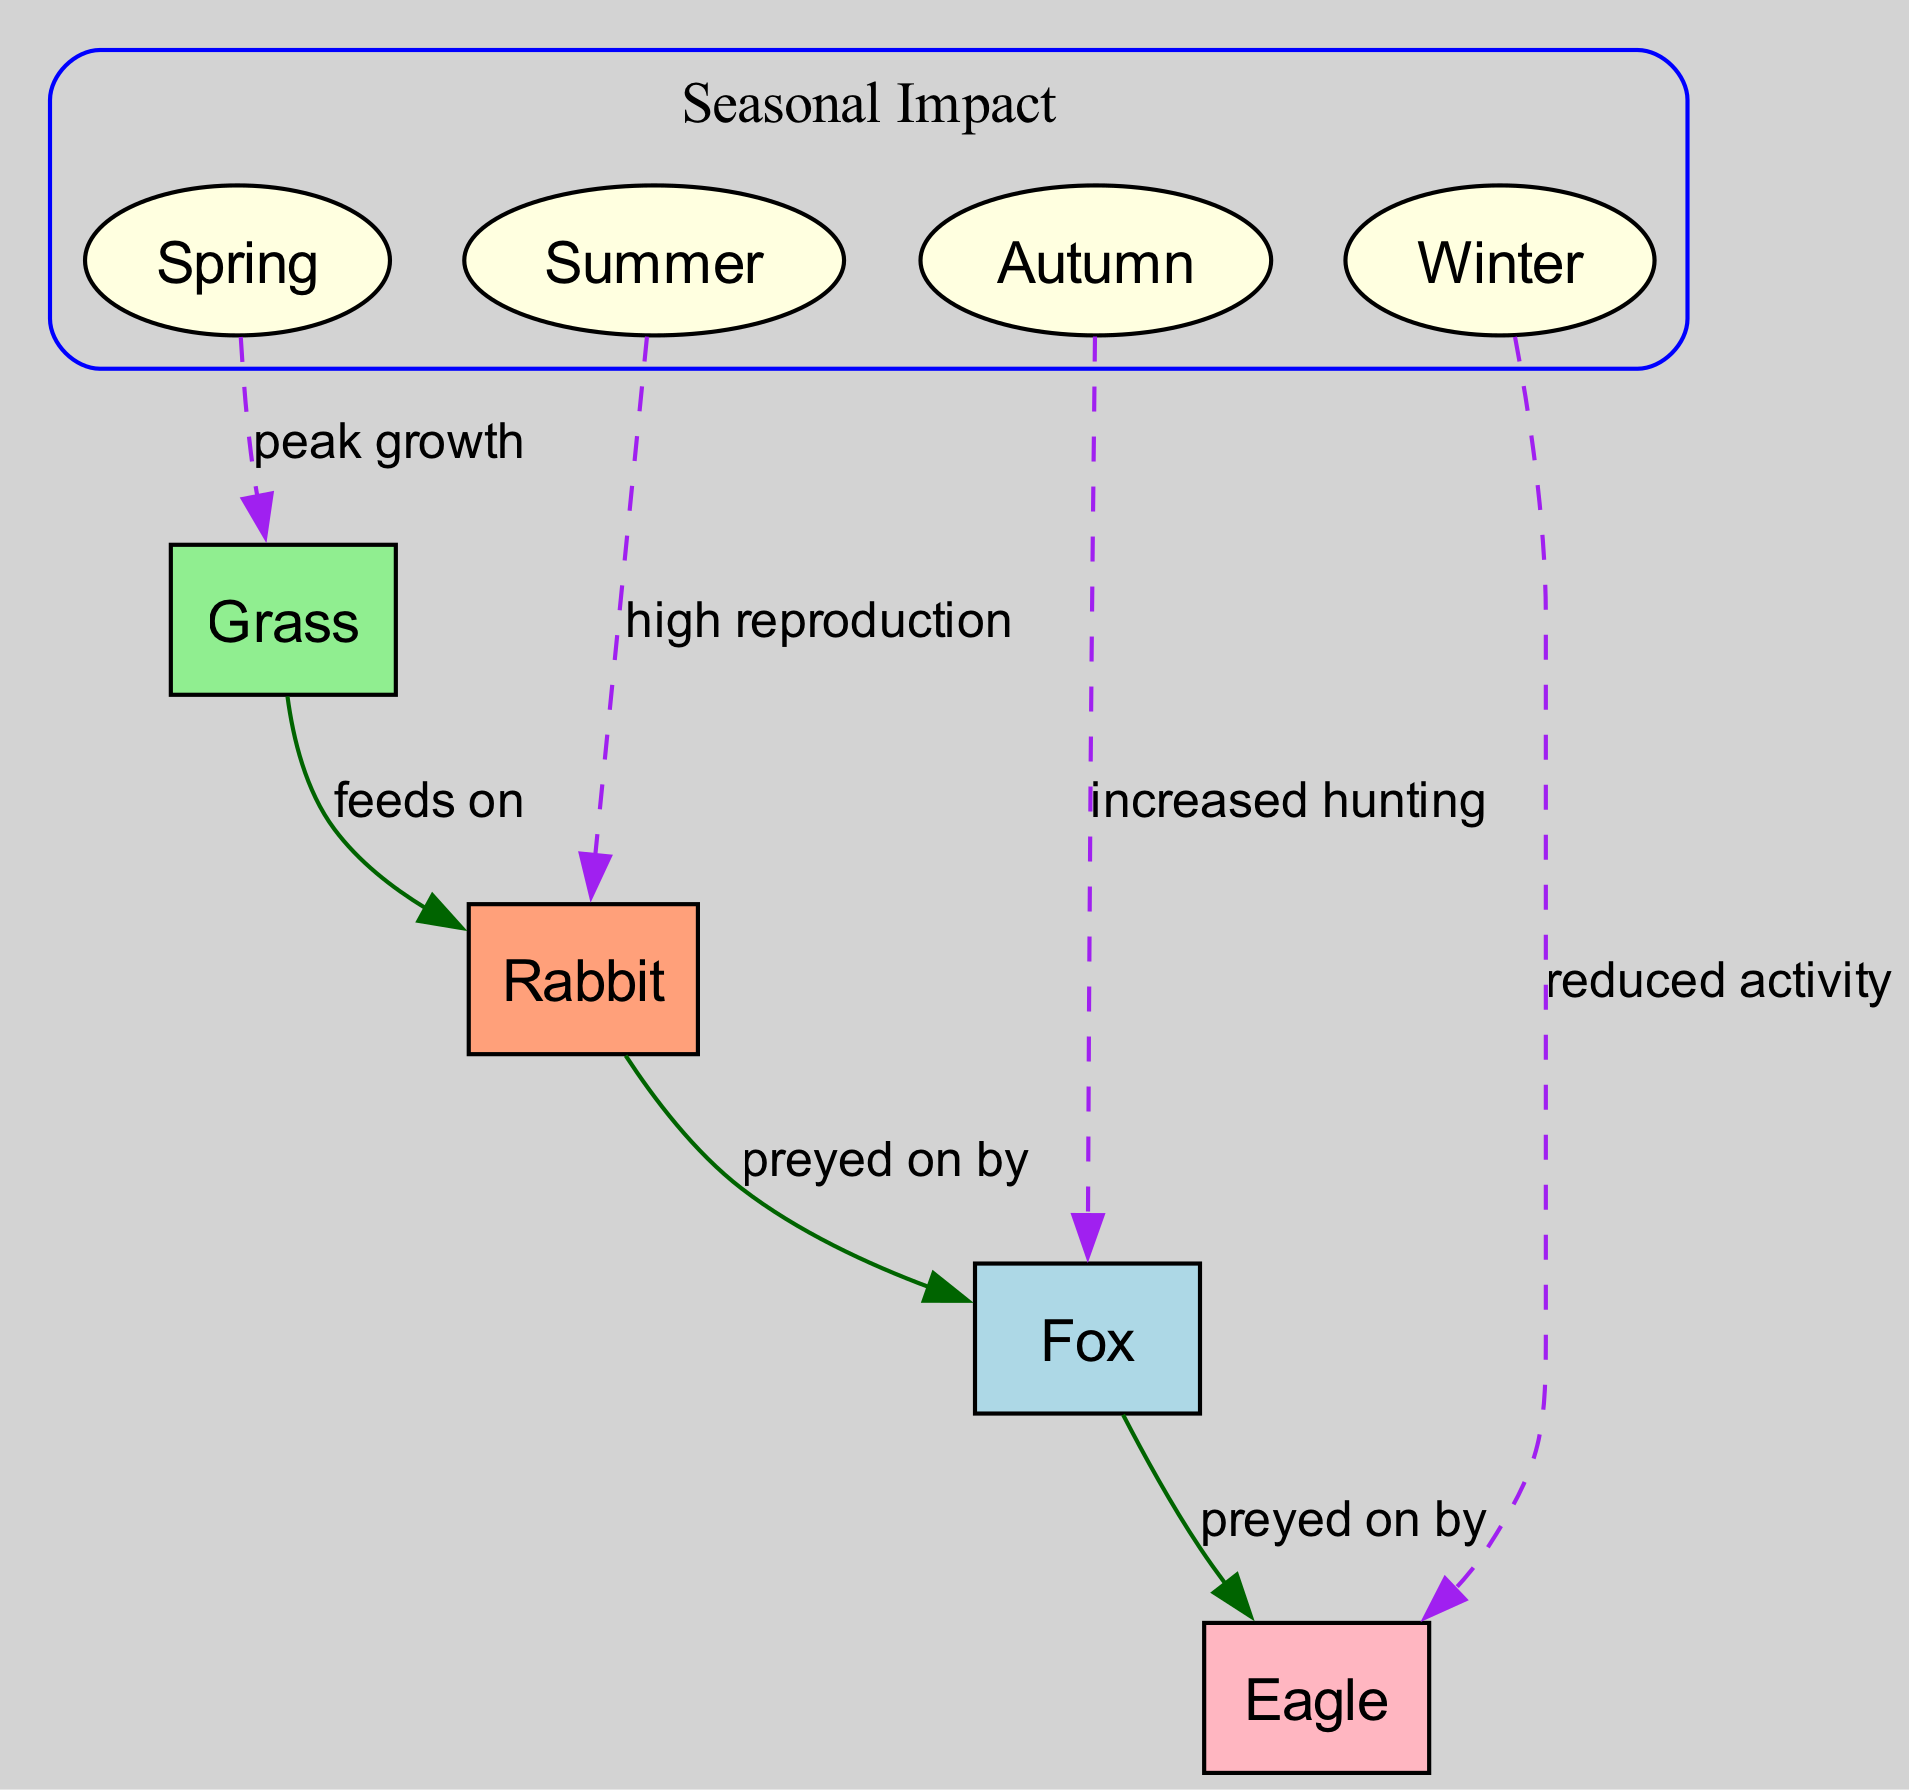What is the main food source for herbivores in the diagram? The diagram shows that the primary food source for herbivores, represented by the Rabbit, is the Grass. This is indicated by the edge labeled "feeds on" connecting the Grass (plant) to Rabbit (herbivore).
Answer: Grass Which season is associated with peak growth of plants? The diagram indicates that "Spring" is the season linked to "peak growth" of plants through an edge labeled accordingly.
Answer: Spring How many different types of nodes are represented in the diagram? The diagram displays four distinct types of nodes: plant (Grass), herbivore (Rabbit), small predator (Fox), and top predator (Eagle), along with four seasons (Spring, Summer, Autumn, Winter). This results in a total of eight nodes.
Answer: Eight During which season do herbivores experience high reproduction? According to the diagram, "Summer" is the season during which herbivores, specifically the Rabbit, experience high reproduction, as denoted by the edge labeled "high reproduction".
Answer: Summer What happens to the top predator during winter according to the diagram? The edge labeled "reduced activity" shows the relationship between "Winter" and the "Eagle" (top predator), indicating that this predator has decreased activity during the winter season.
Answer: Reduced activity Which predator is preyed on by small predators? From the diagram, it is clear that the small predator (Fox) preys on herbivores (Rabbit), which points to the herbivore as the prey for the small predator.
Answer: Rabbit How does autumn impact small predators? The diagram shows an edge labeled "increased hunting" connecting "Autumn" to "Fox" (small predator), indicating that small predators have greater hunting activity during autumn.
Answer: Increased hunting Which node is connected to the edge labeled "preyed on by"? The edge labeled "preyed on by" from the small predator (Fox) leads to the top predator (Eagle), which indicates that the small predator is preyed on by the eagle.
Answer: Eagle 